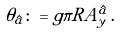<formula> <loc_0><loc_0><loc_500><loc_500>\theta _ { \hat { a } } \colon = g \pi R A ^ { \hat { a } } _ { y } \, .</formula> 